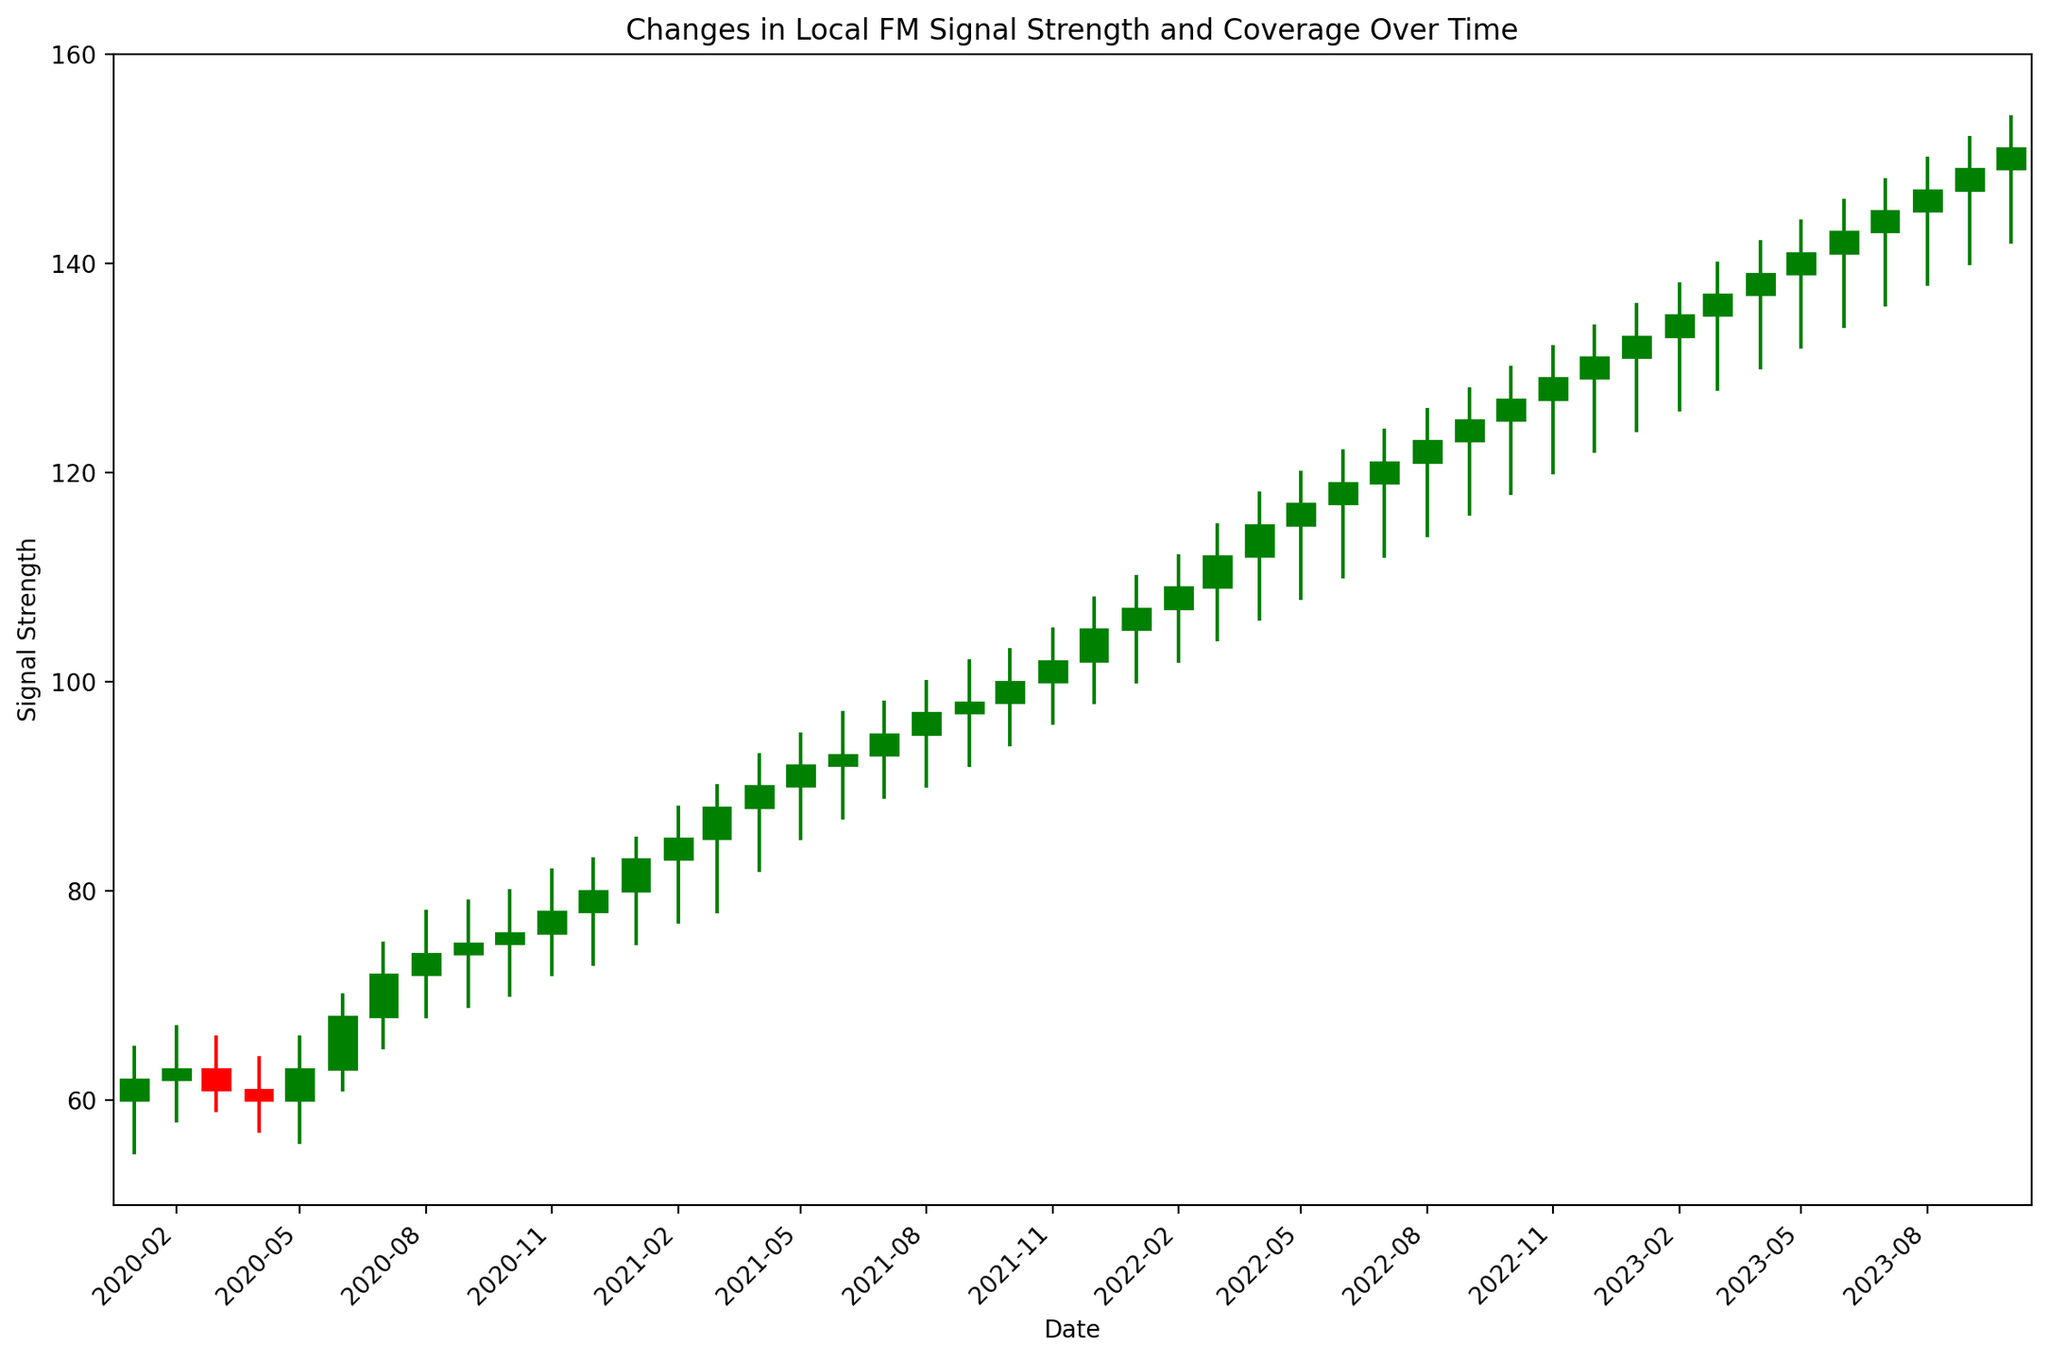What is the closing signal strength in January 2022? Check the candlestick corresponding to January 2022 and observe the closing value at the top of the candlestick rectangle.
Answer: 107 What was the highest signal strength recorded in the plot? Find the tallest high-low line in the entire plot and note the upper value.
Answer: 154 Which month shows the highest increase in signal strength (Open to Close)? Find the candlestick with the biggest height difference between Open and Close where the top of the rectangle is greater than the bottom. Verify this by looking at June 2020 (Open 63, Close 68) and compare it with other months.
Answer: June 2020 Between July 2021 and December 2021, did the signal strength increase or decrease? Observe the closing value in July 2021 (95) and compare it with December 2021 (105). The closing value increased.
Answer: Increase In which month did the signal strength first reach a closing value of 100? Locate the first candlestick where the Close value reaches 100 or more. This is October 2021 (Close 100).
Answer: October 2021 How many times did the signal strength close higher than it opened in 2020? Count the green candlesticks (where Close > Open) in the year 2020. This happens in February, May, June, and July.
Answer: 4 times What is the average opening signal strength for the months in 2022? Sum the opening values for each month in 2022 (105, 107, 109, 112, 115, 117, 119, 121, 123, 125, 127, 129) and divide by the number of months (12). The calculation is (105+107+109+112+115+117+119+121+123+125+127+129) / 12 = 118.
Answer: 118 Which month in 2020 had the lowest low value recorded? Find the shortest low-high line (lowest point) within 2020. The lowest value is in May 2020, where the Low is 56.
Answer: May 2020 Is the signal trend overall increasing or decreasing from January 2020 to October 2023? Compare the first and last closing values. January 2020 has 62, and October 2023 has 151. The trend is increasing.
Answer: Increasing 